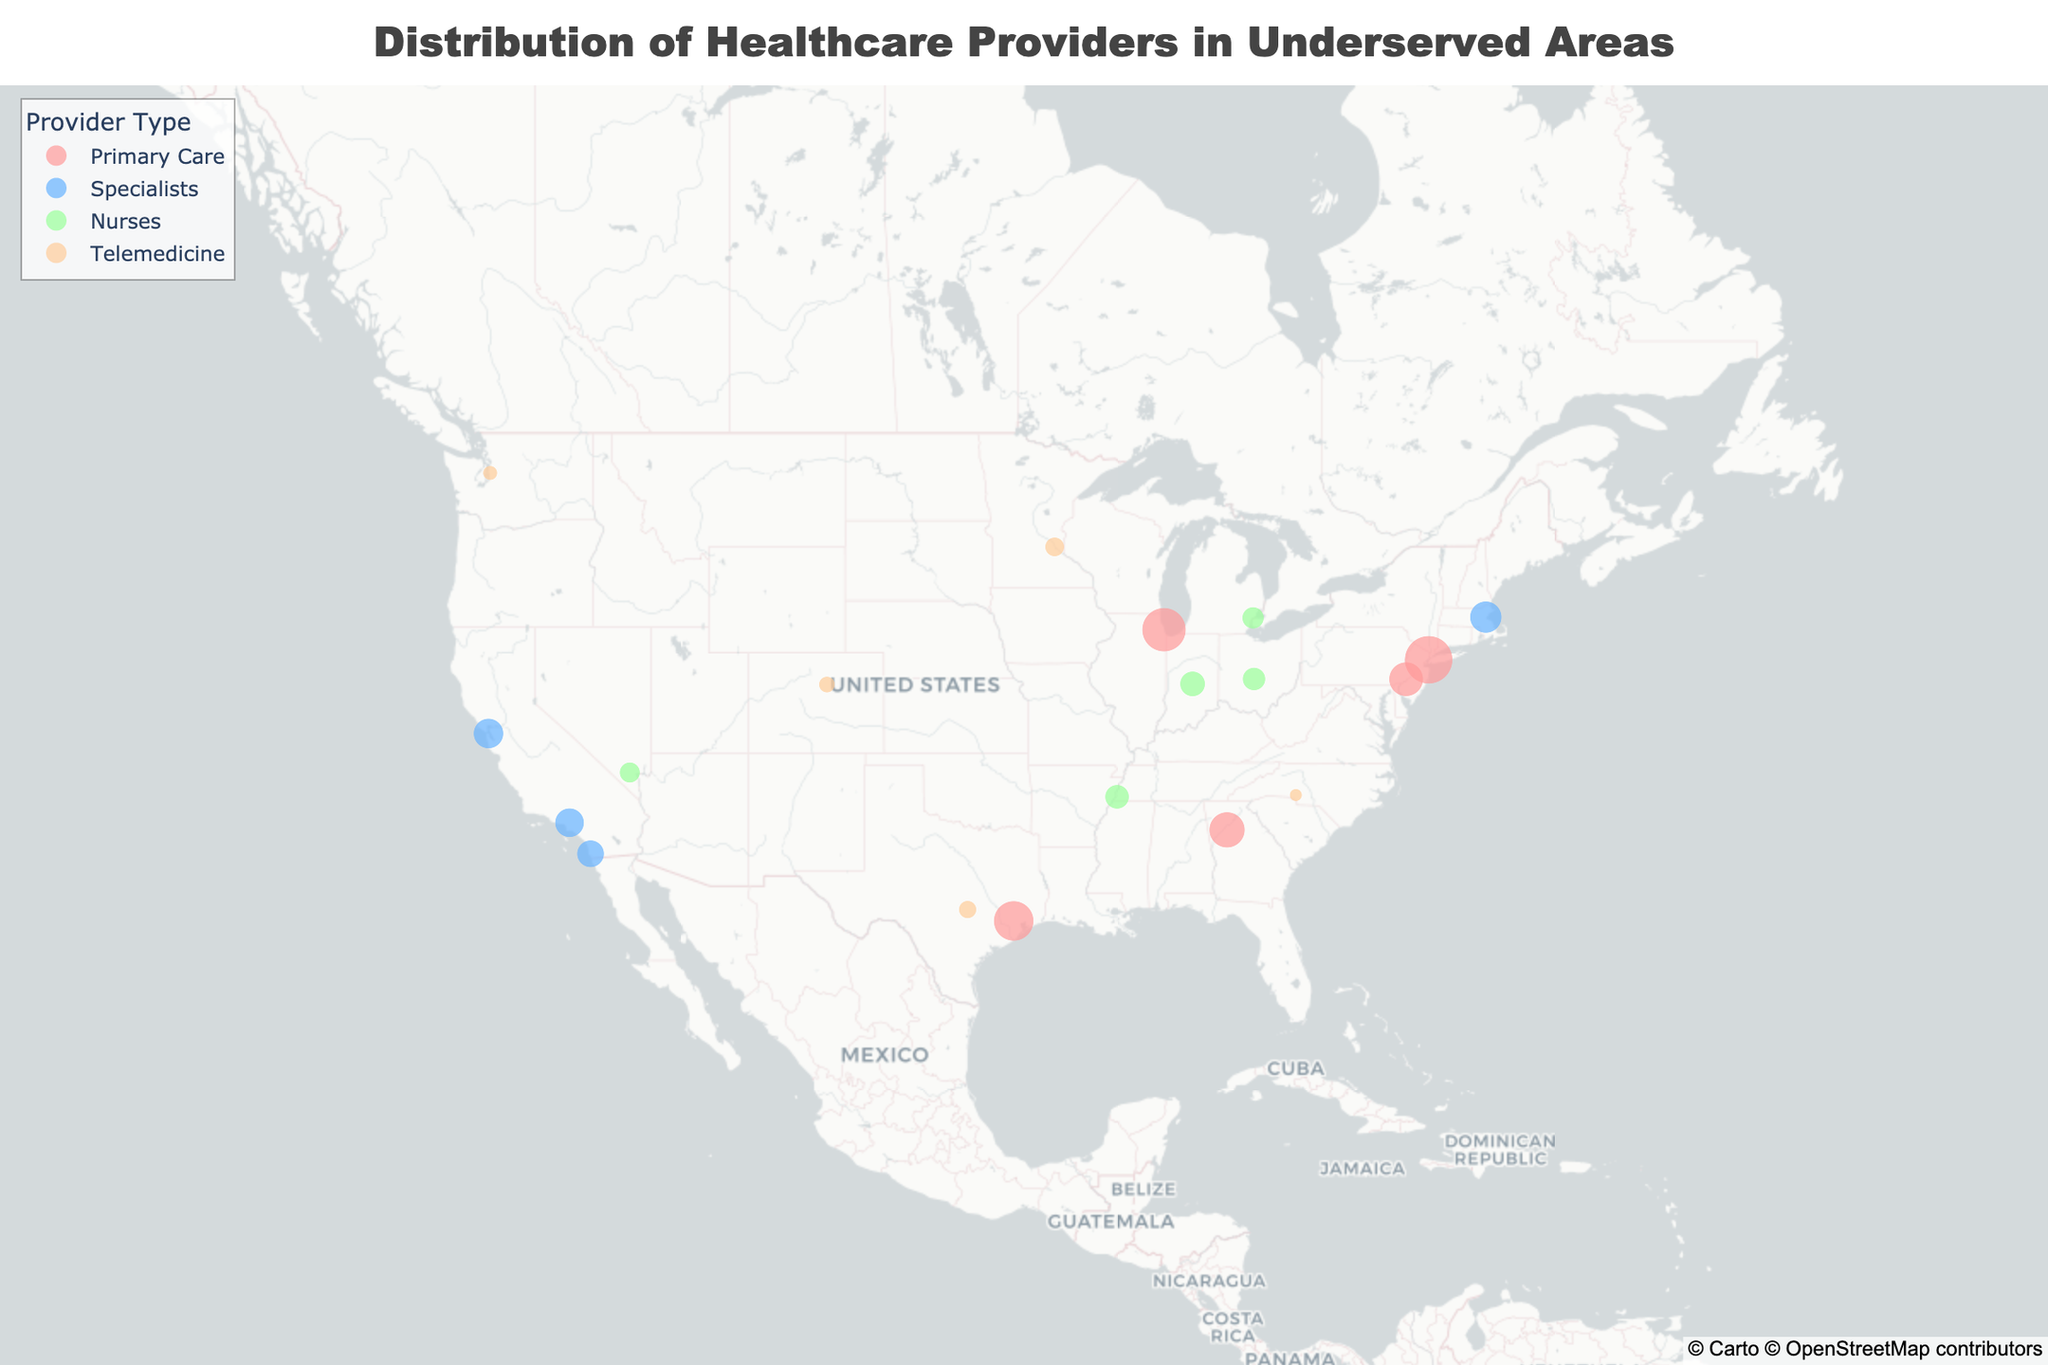What is the title of the figure? The title of a plot gives us a quick understanding of what is being visualized. It is usually found at the top of the figure.
Answer: Distribution of Healthcare Providers in Underserved Areas Which city has the highest number of healthcare providers? Find the city with the largest circle (indicating the number of providers) on the map. It will have the highest count.
Answer: New York City How many states are represented in the plot? Count the unique states mentioned in the hover information when hovering over different points on the map.
Answer: 13 Which provider type has the most providers in New York City? Identify the color representing New York City and use the legend to determine the provider type.
Answer: Primary Care How many Telemedicine providers are in Austin, Texas? Hover over Austin, Texas, on the map to see the number of Telemedicine providers.
Answer: 30 In which state are the cities with the most and least providers located? Locate the city with the largest and smallest circles on the map and check their respective states.
Answer: New York (most), North Carolina (least) How many more Primary Care providers are there in Chicago than in Atlanta? Find the number of Primary Care providers in Chicago and Atlanta, then subtract the latter from the former.
Answer: 60 What is the total number of Telemedicine providers in all the cities combined? Sum the number of Telemedicine providers across all the cities: 35 (Minneapolis) + 30 (Austin) + 25 (Denver) + 20 (Seattle) + 15 (Charlotte).
Answer: 125 Which provider type is represented by the most number of cities? Count the number of cities for each provider type using the colored points on the map.
Answer: Telemedicine Are there more Primary Care providers in Houston than Nurses in Detroit? Compare the number of Primary Care providers in Houston with the number of Nurses in Detroit.
Answer: Yes 